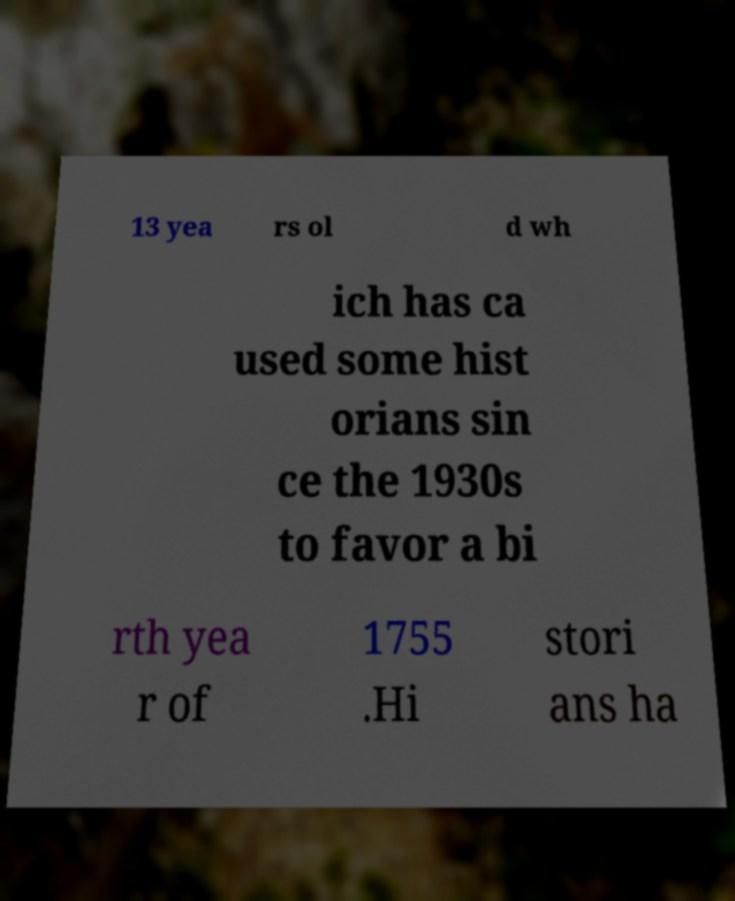What messages or text are displayed in this image? I need them in a readable, typed format. 13 yea rs ol d wh ich has ca used some hist orians sin ce the 1930s to favor a bi rth yea r of 1755 .Hi stori ans ha 